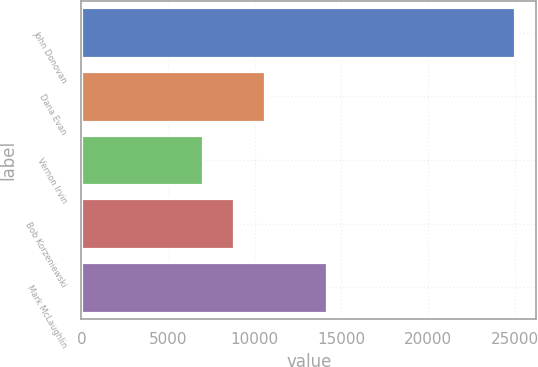Convert chart. <chart><loc_0><loc_0><loc_500><loc_500><bar_chart><fcel>John Donovan<fcel>Dana Evan<fcel>Vernon Irvin<fcel>Bob Korzeniewski<fcel>Mark McLaughlin<nl><fcel>25000<fcel>10600<fcel>7000<fcel>8800<fcel>14200<nl></chart> 